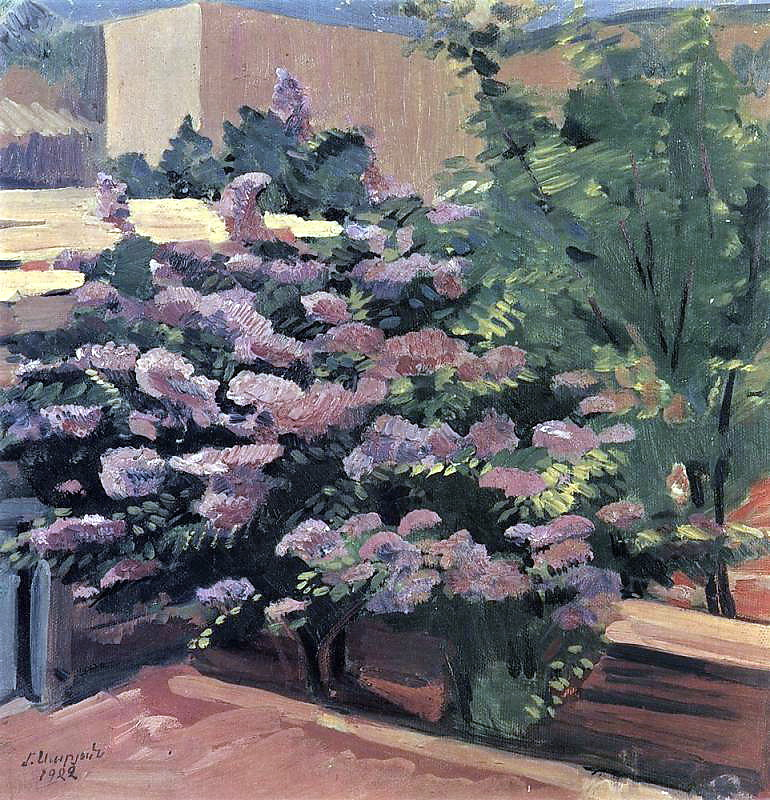Can you tell me more about the artist L. Ury and his style? Lesser Ury was a German-Jewish impressionist painter and printmaker, known for his atmospheric urban scenes and landscapes. Ury's work often depicted scenes from everyday life, imbued with a sense of fleeting moments and emotional depth. He was particularly adept at capturing the interplay of light and shadow, employing loose and expressive brush strokes to convey the impressionist nature of his subjects. His work was celebrated for its ability to evoke the sensory experiences and moods associated with the scenes he painted, whether they were bustling cityscapes or quiet, serene gardens like the one in this painting. 